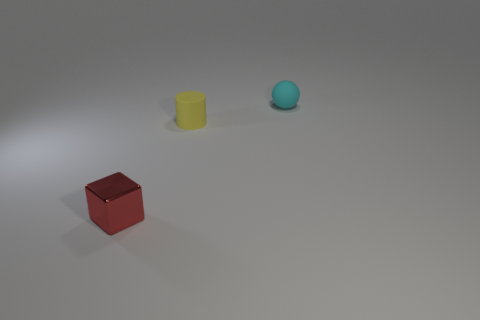How many red things are tiny shiny blocks or large rubber cylinders?
Offer a very short reply. 1. Is the material of the small object that is to the left of the cylinder the same as the cylinder?
Offer a terse response. No. How many other objects are there of the same material as the tiny cyan thing?
Provide a succinct answer. 1. What material is the small cyan ball?
Your answer should be very brief. Rubber. How big is the thing that is left of the small yellow rubber cylinder?
Make the answer very short. Small. What number of rubber cylinders are in front of the rubber object that is right of the small matte cylinder?
Your response must be concise. 1. Is the shape of the matte object in front of the cyan matte object the same as the object to the right of the yellow matte object?
Your answer should be very brief. No. How many objects are both left of the yellow rubber thing and behind the small cylinder?
Your answer should be very brief. 0. There is a cyan matte thing that is the same size as the matte cylinder; what shape is it?
Offer a terse response. Sphere. Are there any spheres on the left side of the yellow matte cylinder?
Your response must be concise. No. 